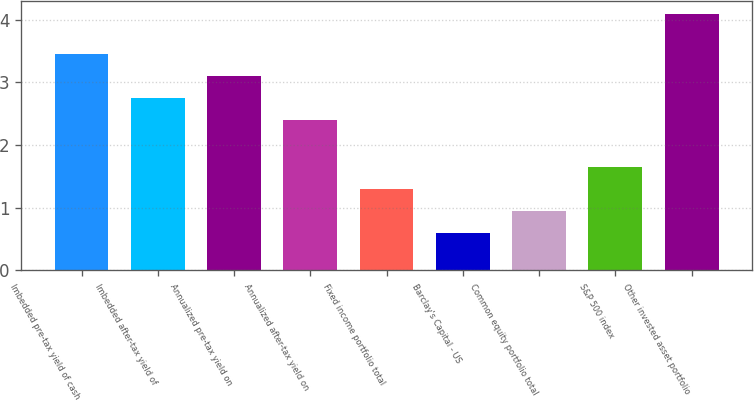Convert chart to OTSL. <chart><loc_0><loc_0><loc_500><loc_500><bar_chart><fcel>Imbedded pre-tax yield of cash<fcel>Imbedded after-tax yield of<fcel>Annualized pre-tax yield on<fcel>Annualized after-tax yield on<fcel>Fixed income portfolio total<fcel>Barclay's Capital - US<fcel>Common equity portfolio total<fcel>S&P 500 index<fcel>Other invested asset portfolio<nl><fcel>3.45<fcel>2.75<fcel>3.1<fcel>2.4<fcel>1.3<fcel>0.6<fcel>0.95<fcel>1.65<fcel>4.1<nl></chart> 